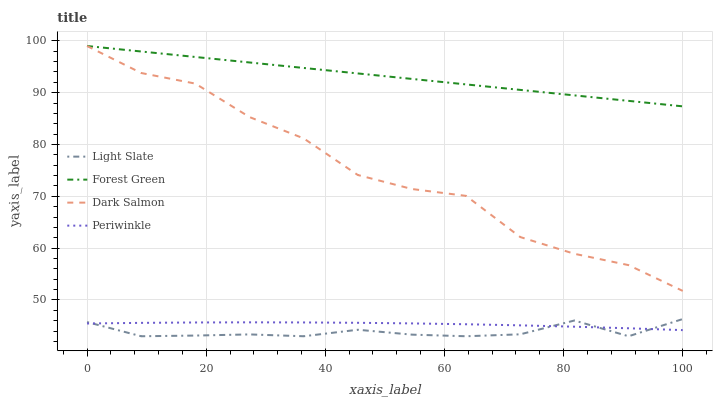Does Light Slate have the minimum area under the curve?
Answer yes or no. Yes. Does Forest Green have the maximum area under the curve?
Answer yes or no. Yes. Does Periwinkle have the minimum area under the curve?
Answer yes or no. No. Does Periwinkle have the maximum area under the curve?
Answer yes or no. No. Is Forest Green the smoothest?
Answer yes or no. Yes. Is Dark Salmon the roughest?
Answer yes or no. Yes. Is Periwinkle the smoothest?
Answer yes or no. No. Is Periwinkle the roughest?
Answer yes or no. No. Does Light Slate have the lowest value?
Answer yes or no. Yes. Does Periwinkle have the lowest value?
Answer yes or no. No. Does Dark Salmon have the highest value?
Answer yes or no. Yes. Does Periwinkle have the highest value?
Answer yes or no. No. Is Light Slate less than Dark Salmon?
Answer yes or no. Yes. Is Dark Salmon greater than Periwinkle?
Answer yes or no. Yes. Does Forest Green intersect Dark Salmon?
Answer yes or no. Yes. Is Forest Green less than Dark Salmon?
Answer yes or no. No. Is Forest Green greater than Dark Salmon?
Answer yes or no. No. Does Light Slate intersect Dark Salmon?
Answer yes or no. No. 